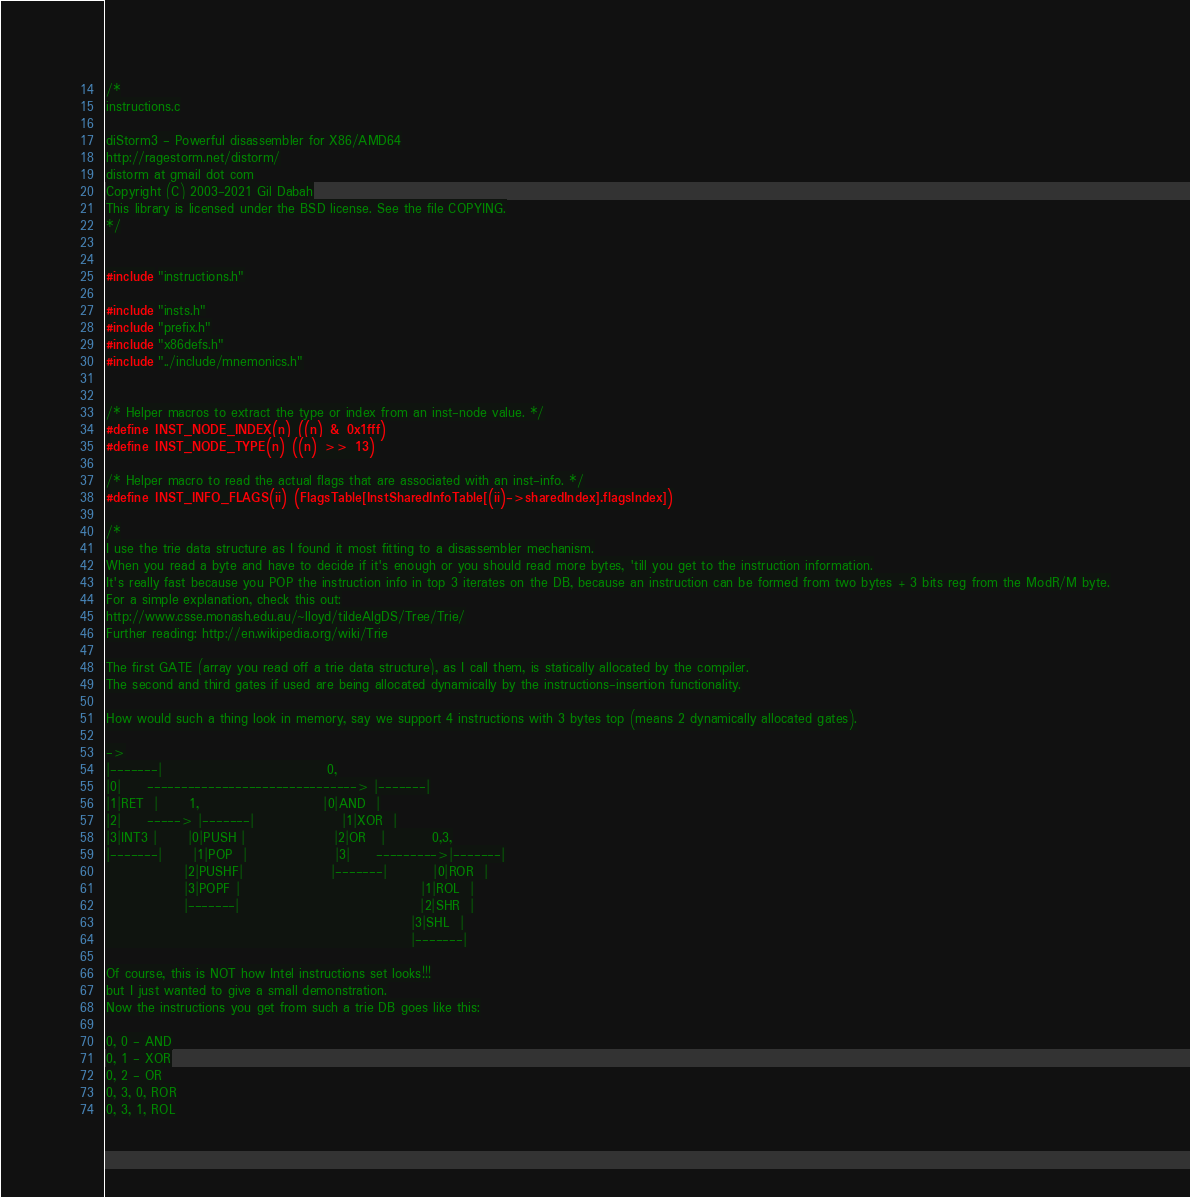<code> <loc_0><loc_0><loc_500><loc_500><_C_>/*
instructions.c

diStorm3 - Powerful disassembler for X86/AMD64
http://ragestorm.net/distorm/
distorm at gmail dot com
Copyright (C) 2003-2021 Gil Dabah
This library is licensed under the BSD license. See the file COPYING.
*/


#include "instructions.h"

#include "insts.h"
#include "prefix.h"
#include "x86defs.h"
#include "../include/mnemonics.h"


/* Helper macros to extract the type or index from an inst-node value. */
#define INST_NODE_INDEX(n) ((n) & 0x1fff)
#define INST_NODE_TYPE(n) ((n) >> 13)

/* Helper macro to read the actual flags that are associated with an inst-info. */
#define INST_INFO_FLAGS(ii) (FlagsTable[InstSharedInfoTable[(ii)->sharedIndex].flagsIndex])

/*
I use the trie data structure as I found it most fitting to a disassembler mechanism.
When you read a byte and have to decide if it's enough or you should read more bytes, 'till you get to the instruction information.
It's really fast because you POP the instruction info in top 3 iterates on the DB, because an instruction can be formed from two bytes + 3 bits reg from the ModR/M byte.
For a simple explanation, check this out:
http://www.csse.monash.edu.au/~lloyd/tildeAlgDS/Tree/Trie/
Further reading: http://en.wikipedia.org/wiki/Trie

The first GATE (array you read off a trie data structure), as I call them, is statically allocated by the compiler.
The second and third gates if used are being allocated dynamically by the instructions-insertion functionality.

How would such a thing look in memory, say we support 4 instructions with 3 bytes top (means 2 dynamically allocated gates).

->
|-------|                                0,
|0|     -------------------------------> |-------|
|1|RET  |      1,                        |0|AND  |
|2|     -----> |-------|                 |1|XOR  |
|3|INT3 |      |0|PUSH |                 |2|OR   |         0,3,
|-------|      |1|POP  |                 |3|     --------->|-------|
               |2|PUSHF|                 |-------|         |0|ROR  |
               |3|POPF |                                   |1|ROL  |
               |-------|                                   |2|SHR  |
                                                           |3|SHL  |
                                                           |-------|

Of course, this is NOT how Intel instructions set looks!!!
but I just wanted to give a small demonstration.
Now the instructions you get from such a trie DB goes like this:

0, 0 - AND
0, 1 - XOR
0, 2 - OR
0, 3, 0, ROR
0, 3, 1, ROL</code> 